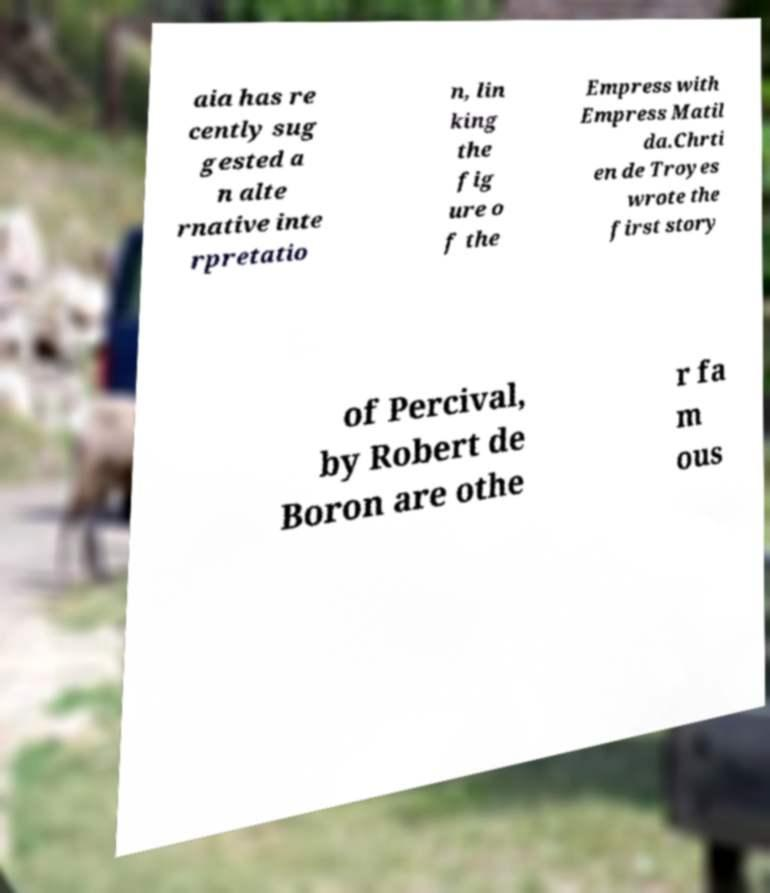There's text embedded in this image that I need extracted. Can you transcribe it verbatim? aia has re cently sug gested a n alte rnative inte rpretatio n, lin king the fig ure o f the Empress with Empress Matil da.Chrti en de Troyes wrote the first story of Percival, by Robert de Boron are othe r fa m ous 